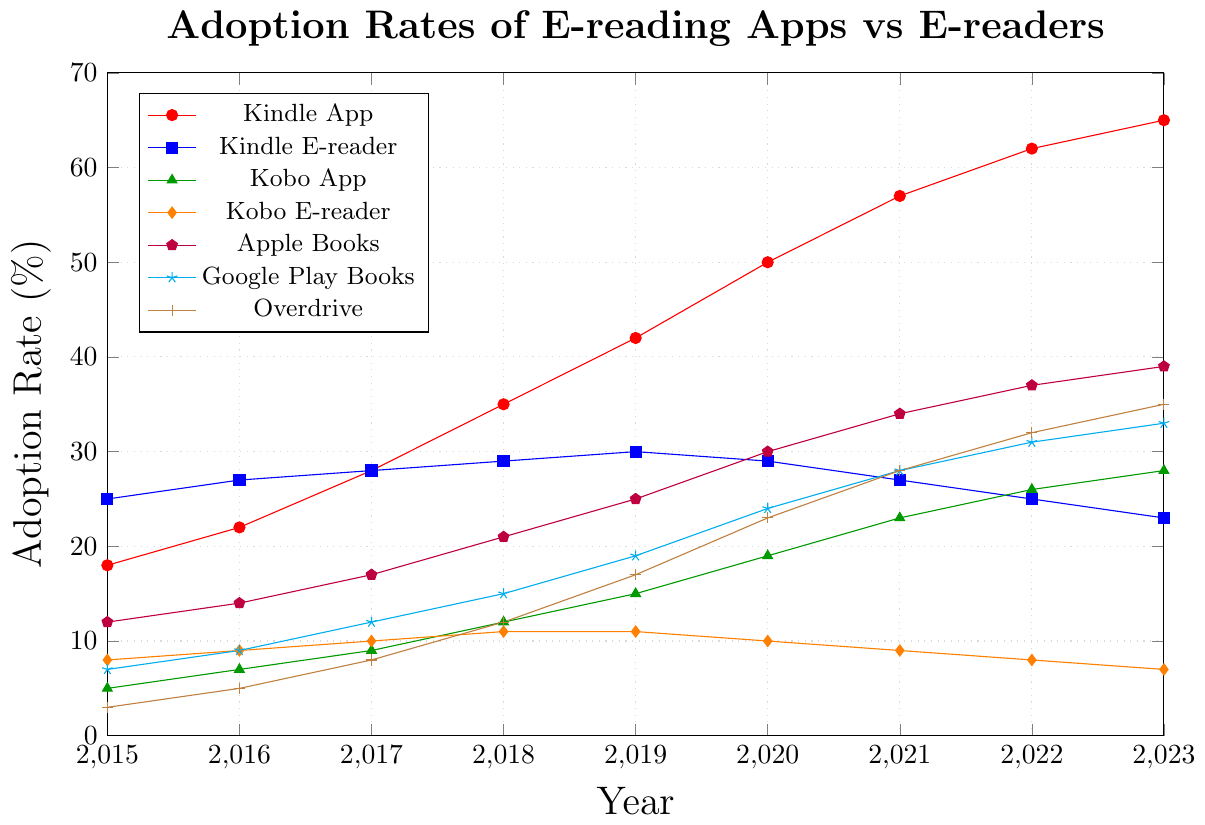Which e-reading platform has shown the highest increase in adoption rate from 2015 to 2023? To find the highest increase, we subtract the 2015 adoption rate from the 2023 adoption rate for each platform. The increases are: Kindle App: 65-18 = 47, Kindle E-reader: 23-25 = -2, Kobo App: 28-5 = 23, Kobo E-reader: 7-8 = -1, Apple Books: 39-12 = 27, Google Play Books: 33-7 = 26, Overdrive: 35-3 = 32. The highest increase is for the Kindle App with 47%.
Answer: Kindle App Which platform had the highest adoption rate in 2020? By visually comparing the heights of the data points at the 2020 mark for each platform, the Kindle App has the highest adoption rate at 50%.
Answer: Kindle App Compare the adoption rates of Kindle App and Apple Books in 2022. Which one is higher and by how much? In 2022, the adoption rates are Kindle App: 62 and Apple Books: 37. Kindle App has a higher adoption rate. The difference is 62 - 37 = 25.
Answer: Kindle App by 25 In which year did the Kobo App’s adoption rate exceed the Kindle E-reader’s adoption rate for the first time? We compare the adoption rates for each year. The adoption rate for the Kobo App exceeds that of the Kindle E-reader for the first time in 2020: Kobo App: 19, Kindle E-reader: 29. This trend continues in subsequent years where Kobo App continually stays higher than Kindle E-reader starting 2020.
Answer: 2020 What is the average adoption rate of Overdrive from 2015 to 2023? We calculate the sum of Overdrive's adoption rates from 2015 to 2023 and then divide by the number of years (9). Sum = 3 + 5 + 8 + 12 + 17 + 23 + 28 + 32 + 35 = 163. The average is 163 / 9 ≈ 18.11.
Answer: 18.11 How does the adoption trend of dedicated e-readers compare to e-reading apps from 2015 to 2023? By analyzing the overall trend, we observe that dedicated e-readers (Kindle E-reader and Kobo E-reader) either remained stagnant or decreased slightly. In contrast, the e-reading apps (Kindle App, Kobo App, Apple Books, Google Play Books, Overdrive) show significant and consistent increases over the years.
Answer: E-reading apps increased, while dedicated e-readers remained stagnant or decreased From 2018 to 2021, which e-reading platform saw the most rapid increase in adoption rates? We calculate the increases over 2018 to 2021 for each platform: Kindle App: 57-35 = 22, Kindle E-reader: 27-29 = -2, Kobo App: 23-12 = 11, Kobo E-reader: 9-11 = -2, Apple Books: 34-21 = 13, Google Play Books: 28-15 = 13, Overdrive: 28-12 = 16. The Kindle App has the highest increase over this period.
Answer: Kindle App Did any platform experience a decline in adoption rate from 2019 to 2023? If yes, which one(s)? We look at the changes from 2019 to 2023 for each platform: Kindle App: 65-42 = 23, Kindle E-reader: 23-30 = -7, Kobo App: 28-15 = 13, Kobo E-reader: 7-11 = -4, Apple Books: 39-25 = 14, Google Play Books: 33-19 = 14, Overdrive: 35-17 = 18. Both Kindle E-reader and Kobo E-reader experienced declines.
Answer: Kindle E-reader and Kobo E-reader 